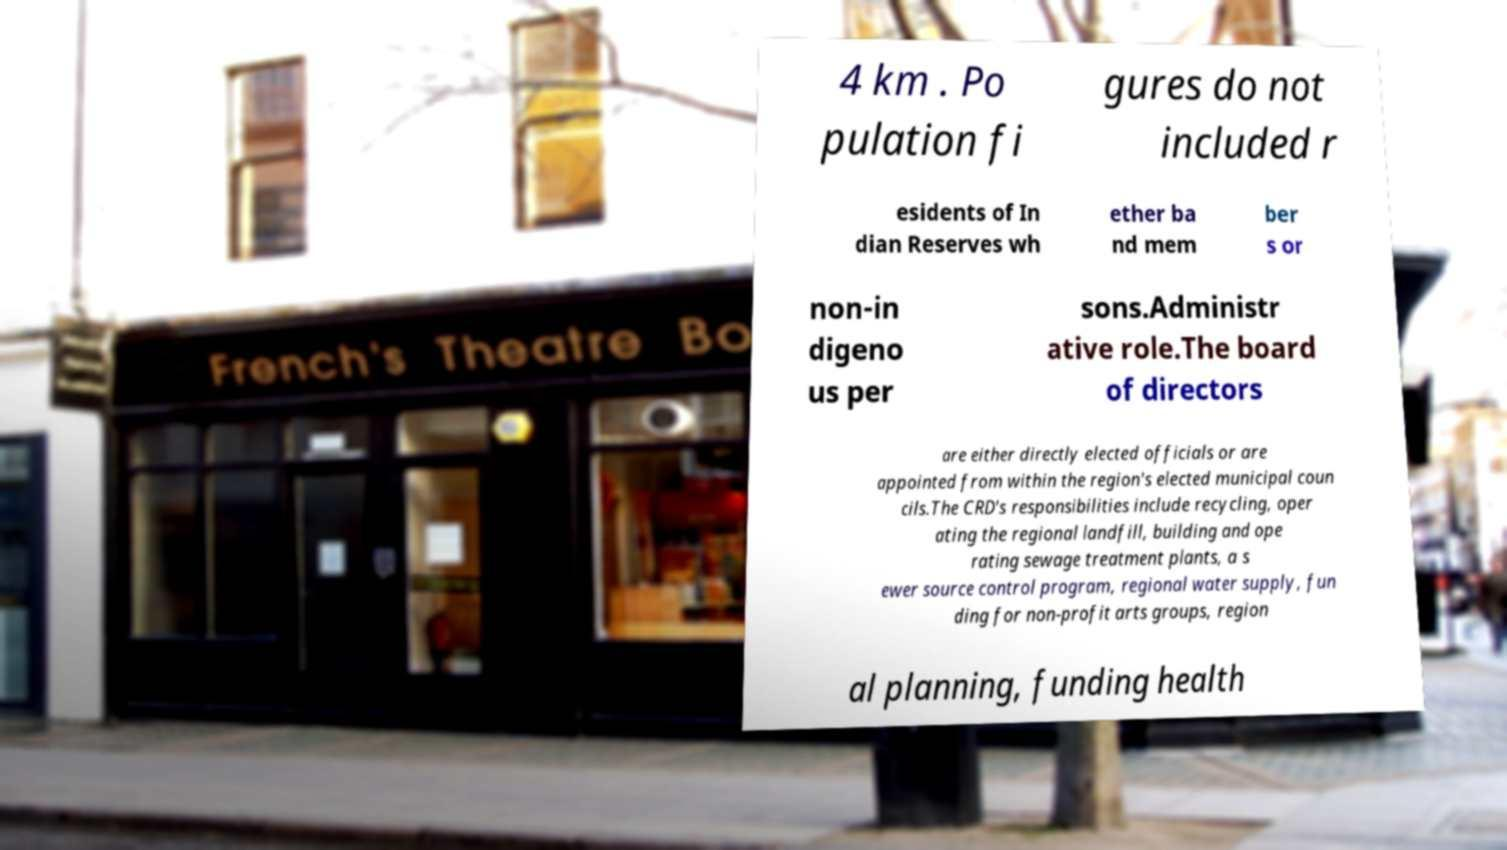What messages or text are displayed in this image? I need them in a readable, typed format. 4 km . Po pulation fi gures do not included r esidents of In dian Reserves wh ether ba nd mem ber s or non-in digeno us per sons.Administr ative role.The board of directors are either directly elected officials or are appointed from within the region's elected municipal coun cils.The CRD's responsibilities include recycling, oper ating the regional landfill, building and ope rating sewage treatment plants, a s ewer source control program, regional water supply, fun ding for non-profit arts groups, region al planning, funding health 